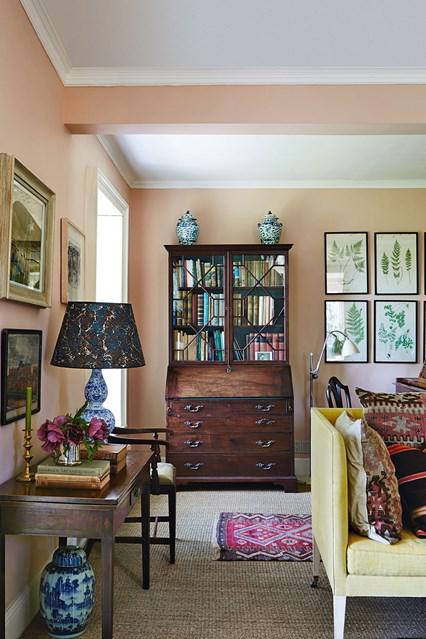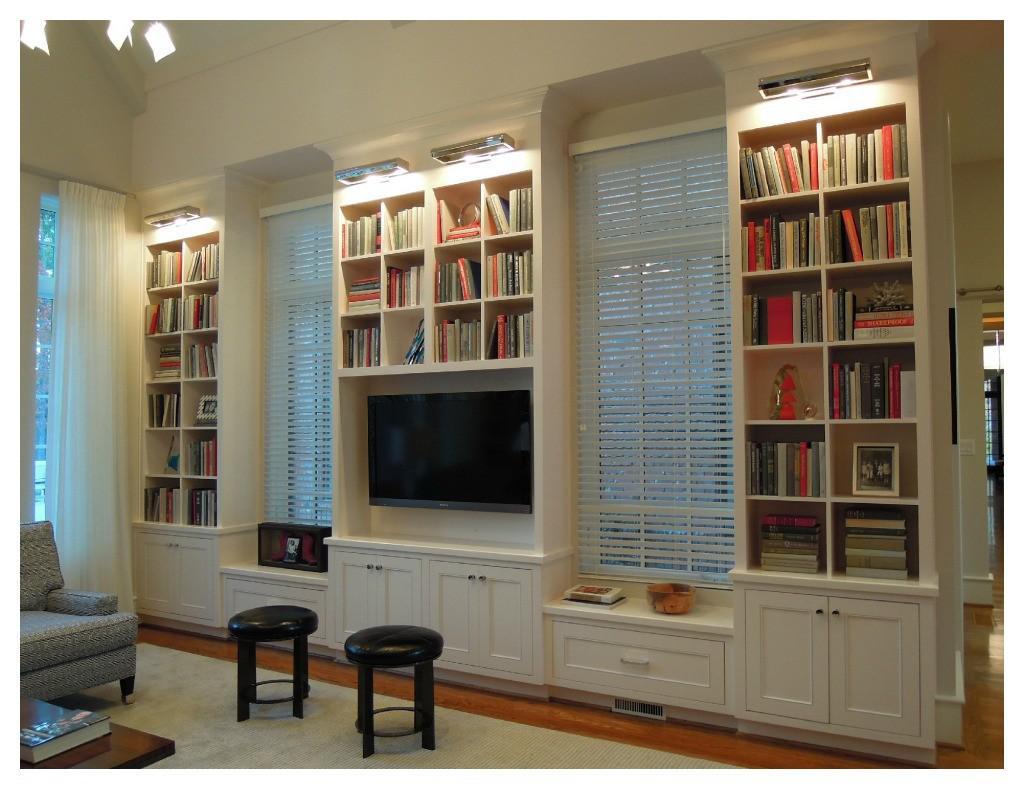The first image is the image on the left, the second image is the image on the right. Considering the images on both sides, is "In one image, a television is centered in a white wall unit that has open shelving in the upper section and solid panel doors and drawers across the bottom" valid? Answer yes or no. Yes. 